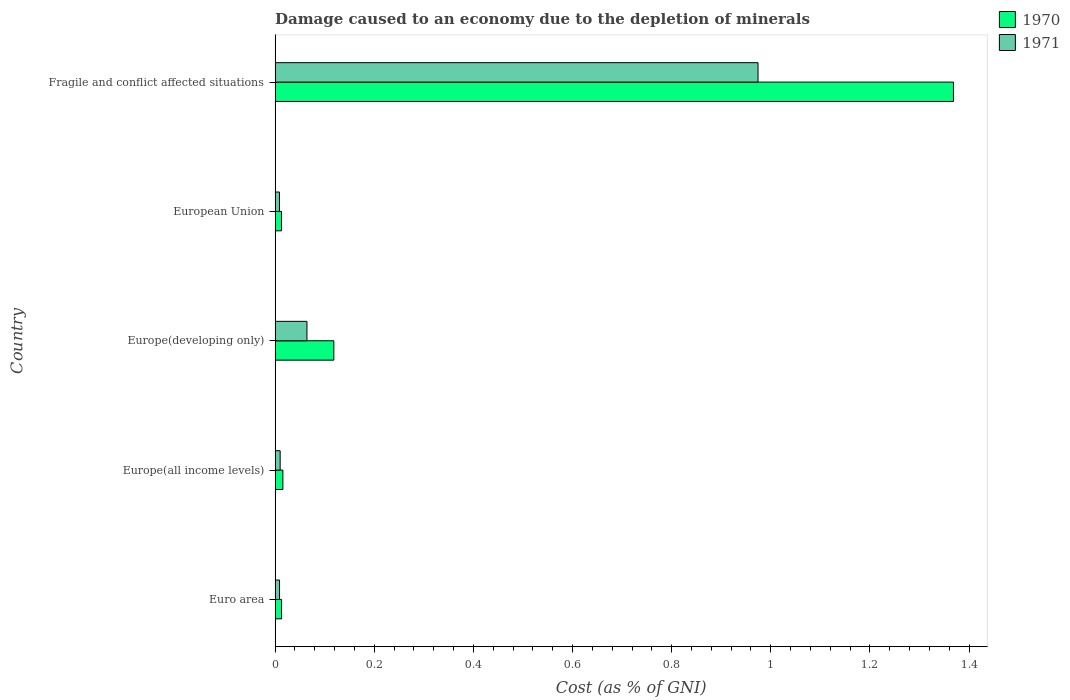How many different coloured bars are there?
Your answer should be compact. 2. How many bars are there on the 5th tick from the bottom?
Give a very brief answer. 2. What is the label of the 2nd group of bars from the top?
Provide a succinct answer. European Union. In how many cases, is the number of bars for a given country not equal to the number of legend labels?
Provide a succinct answer. 0. What is the cost of damage caused due to the depletion of minerals in 1970 in Fragile and conflict affected situations?
Make the answer very short. 1.37. Across all countries, what is the maximum cost of damage caused due to the depletion of minerals in 1971?
Your answer should be compact. 0.97. Across all countries, what is the minimum cost of damage caused due to the depletion of minerals in 1970?
Make the answer very short. 0.01. In which country was the cost of damage caused due to the depletion of minerals in 1971 maximum?
Keep it short and to the point. Fragile and conflict affected situations. In which country was the cost of damage caused due to the depletion of minerals in 1970 minimum?
Keep it short and to the point. European Union. What is the total cost of damage caused due to the depletion of minerals in 1971 in the graph?
Provide a succinct answer. 1.07. What is the difference between the cost of damage caused due to the depletion of minerals in 1970 in Europe(all income levels) and that in European Union?
Provide a short and direct response. 0. What is the difference between the cost of damage caused due to the depletion of minerals in 1970 in Europe(developing only) and the cost of damage caused due to the depletion of minerals in 1971 in European Union?
Give a very brief answer. 0.11. What is the average cost of damage caused due to the depletion of minerals in 1971 per country?
Offer a terse response. 0.21. What is the difference between the cost of damage caused due to the depletion of minerals in 1971 and cost of damage caused due to the depletion of minerals in 1970 in Euro area?
Offer a very short reply. -0. In how many countries, is the cost of damage caused due to the depletion of minerals in 1970 greater than 0.12 %?
Ensure brevity in your answer.  1. What is the ratio of the cost of damage caused due to the depletion of minerals in 1970 in Europe(all income levels) to that in European Union?
Your answer should be very brief. 1.22. Is the cost of damage caused due to the depletion of minerals in 1970 in Europe(all income levels) less than that in European Union?
Make the answer very short. No. What is the difference between the highest and the second highest cost of damage caused due to the depletion of minerals in 1971?
Offer a very short reply. 0.91. What is the difference between the highest and the lowest cost of damage caused due to the depletion of minerals in 1971?
Keep it short and to the point. 0.97. What does the 2nd bar from the top in Europe(developing only) represents?
Offer a very short reply. 1970. What does the 2nd bar from the bottom in Euro area represents?
Offer a terse response. 1971. Are all the bars in the graph horizontal?
Offer a terse response. Yes. How many countries are there in the graph?
Your answer should be very brief. 5. Are the values on the major ticks of X-axis written in scientific E-notation?
Offer a very short reply. No. Does the graph contain any zero values?
Your response must be concise. No. Does the graph contain grids?
Your response must be concise. No. What is the title of the graph?
Ensure brevity in your answer.  Damage caused to an economy due to the depletion of minerals. What is the label or title of the X-axis?
Make the answer very short. Cost (as % of GNI). What is the label or title of the Y-axis?
Provide a short and direct response. Country. What is the Cost (as % of GNI) in 1970 in Euro area?
Ensure brevity in your answer.  0.01. What is the Cost (as % of GNI) of 1971 in Euro area?
Ensure brevity in your answer.  0.01. What is the Cost (as % of GNI) of 1970 in Europe(all income levels)?
Provide a succinct answer. 0.02. What is the Cost (as % of GNI) of 1971 in Europe(all income levels)?
Ensure brevity in your answer.  0.01. What is the Cost (as % of GNI) of 1970 in Europe(developing only)?
Offer a terse response. 0.12. What is the Cost (as % of GNI) of 1971 in Europe(developing only)?
Keep it short and to the point. 0.06. What is the Cost (as % of GNI) of 1970 in European Union?
Your answer should be very brief. 0.01. What is the Cost (as % of GNI) in 1971 in European Union?
Your response must be concise. 0.01. What is the Cost (as % of GNI) of 1970 in Fragile and conflict affected situations?
Offer a terse response. 1.37. What is the Cost (as % of GNI) of 1971 in Fragile and conflict affected situations?
Keep it short and to the point. 0.97. Across all countries, what is the maximum Cost (as % of GNI) of 1970?
Ensure brevity in your answer.  1.37. Across all countries, what is the maximum Cost (as % of GNI) of 1971?
Give a very brief answer. 0.97. Across all countries, what is the minimum Cost (as % of GNI) in 1970?
Offer a terse response. 0.01. Across all countries, what is the minimum Cost (as % of GNI) of 1971?
Your response must be concise. 0.01. What is the total Cost (as % of GNI) of 1970 in the graph?
Provide a short and direct response. 1.53. What is the total Cost (as % of GNI) of 1971 in the graph?
Offer a terse response. 1.07. What is the difference between the Cost (as % of GNI) in 1970 in Euro area and that in Europe(all income levels)?
Ensure brevity in your answer.  -0. What is the difference between the Cost (as % of GNI) in 1971 in Euro area and that in Europe(all income levels)?
Your answer should be compact. -0. What is the difference between the Cost (as % of GNI) of 1970 in Euro area and that in Europe(developing only)?
Your answer should be very brief. -0.11. What is the difference between the Cost (as % of GNI) of 1971 in Euro area and that in Europe(developing only)?
Offer a terse response. -0.06. What is the difference between the Cost (as % of GNI) of 1970 in Euro area and that in Fragile and conflict affected situations?
Offer a very short reply. -1.36. What is the difference between the Cost (as % of GNI) of 1971 in Euro area and that in Fragile and conflict affected situations?
Provide a short and direct response. -0.97. What is the difference between the Cost (as % of GNI) in 1970 in Europe(all income levels) and that in Europe(developing only)?
Provide a succinct answer. -0.1. What is the difference between the Cost (as % of GNI) in 1971 in Europe(all income levels) and that in Europe(developing only)?
Make the answer very short. -0.05. What is the difference between the Cost (as % of GNI) of 1970 in Europe(all income levels) and that in European Union?
Give a very brief answer. 0. What is the difference between the Cost (as % of GNI) of 1971 in Europe(all income levels) and that in European Union?
Offer a very short reply. 0. What is the difference between the Cost (as % of GNI) in 1970 in Europe(all income levels) and that in Fragile and conflict affected situations?
Offer a very short reply. -1.35. What is the difference between the Cost (as % of GNI) in 1971 in Europe(all income levels) and that in Fragile and conflict affected situations?
Keep it short and to the point. -0.96. What is the difference between the Cost (as % of GNI) in 1970 in Europe(developing only) and that in European Union?
Provide a short and direct response. 0.11. What is the difference between the Cost (as % of GNI) of 1971 in Europe(developing only) and that in European Union?
Ensure brevity in your answer.  0.06. What is the difference between the Cost (as % of GNI) in 1970 in Europe(developing only) and that in Fragile and conflict affected situations?
Your answer should be very brief. -1.25. What is the difference between the Cost (as % of GNI) of 1971 in Europe(developing only) and that in Fragile and conflict affected situations?
Your answer should be very brief. -0.91. What is the difference between the Cost (as % of GNI) in 1970 in European Union and that in Fragile and conflict affected situations?
Your answer should be very brief. -1.36. What is the difference between the Cost (as % of GNI) of 1971 in European Union and that in Fragile and conflict affected situations?
Provide a succinct answer. -0.97. What is the difference between the Cost (as % of GNI) in 1970 in Euro area and the Cost (as % of GNI) in 1971 in Europe(all income levels)?
Your answer should be very brief. 0. What is the difference between the Cost (as % of GNI) of 1970 in Euro area and the Cost (as % of GNI) of 1971 in Europe(developing only)?
Your answer should be very brief. -0.05. What is the difference between the Cost (as % of GNI) of 1970 in Euro area and the Cost (as % of GNI) of 1971 in European Union?
Ensure brevity in your answer.  0. What is the difference between the Cost (as % of GNI) in 1970 in Euro area and the Cost (as % of GNI) in 1971 in Fragile and conflict affected situations?
Offer a very short reply. -0.96. What is the difference between the Cost (as % of GNI) of 1970 in Europe(all income levels) and the Cost (as % of GNI) of 1971 in Europe(developing only)?
Offer a very short reply. -0.05. What is the difference between the Cost (as % of GNI) of 1970 in Europe(all income levels) and the Cost (as % of GNI) of 1971 in European Union?
Your response must be concise. 0.01. What is the difference between the Cost (as % of GNI) in 1970 in Europe(all income levels) and the Cost (as % of GNI) in 1971 in Fragile and conflict affected situations?
Keep it short and to the point. -0.96. What is the difference between the Cost (as % of GNI) in 1970 in Europe(developing only) and the Cost (as % of GNI) in 1971 in European Union?
Make the answer very short. 0.11. What is the difference between the Cost (as % of GNI) in 1970 in Europe(developing only) and the Cost (as % of GNI) in 1971 in Fragile and conflict affected situations?
Keep it short and to the point. -0.86. What is the difference between the Cost (as % of GNI) in 1970 in European Union and the Cost (as % of GNI) in 1971 in Fragile and conflict affected situations?
Make the answer very short. -0.96. What is the average Cost (as % of GNI) in 1970 per country?
Offer a very short reply. 0.31. What is the average Cost (as % of GNI) in 1971 per country?
Make the answer very short. 0.21. What is the difference between the Cost (as % of GNI) of 1970 and Cost (as % of GNI) of 1971 in Euro area?
Ensure brevity in your answer.  0. What is the difference between the Cost (as % of GNI) of 1970 and Cost (as % of GNI) of 1971 in Europe(all income levels)?
Your answer should be very brief. 0.01. What is the difference between the Cost (as % of GNI) of 1970 and Cost (as % of GNI) of 1971 in Europe(developing only)?
Your response must be concise. 0.05. What is the difference between the Cost (as % of GNI) in 1970 and Cost (as % of GNI) in 1971 in European Union?
Your answer should be very brief. 0. What is the difference between the Cost (as % of GNI) of 1970 and Cost (as % of GNI) of 1971 in Fragile and conflict affected situations?
Keep it short and to the point. 0.39. What is the ratio of the Cost (as % of GNI) in 1970 in Euro area to that in Europe(all income levels)?
Keep it short and to the point. 0.83. What is the ratio of the Cost (as % of GNI) in 1971 in Euro area to that in Europe(all income levels)?
Your answer should be very brief. 0.88. What is the ratio of the Cost (as % of GNI) in 1970 in Euro area to that in Europe(developing only)?
Your answer should be compact. 0.11. What is the ratio of the Cost (as % of GNI) in 1971 in Euro area to that in Europe(developing only)?
Make the answer very short. 0.14. What is the ratio of the Cost (as % of GNI) of 1971 in Euro area to that in European Union?
Ensure brevity in your answer.  1.02. What is the ratio of the Cost (as % of GNI) in 1970 in Euro area to that in Fragile and conflict affected situations?
Your answer should be very brief. 0.01. What is the ratio of the Cost (as % of GNI) of 1971 in Euro area to that in Fragile and conflict affected situations?
Your response must be concise. 0.01. What is the ratio of the Cost (as % of GNI) of 1970 in Europe(all income levels) to that in Europe(developing only)?
Offer a very short reply. 0.13. What is the ratio of the Cost (as % of GNI) of 1971 in Europe(all income levels) to that in Europe(developing only)?
Provide a succinct answer. 0.16. What is the ratio of the Cost (as % of GNI) in 1970 in Europe(all income levels) to that in European Union?
Your answer should be very brief. 1.22. What is the ratio of the Cost (as % of GNI) in 1971 in Europe(all income levels) to that in European Union?
Your answer should be very brief. 1.16. What is the ratio of the Cost (as % of GNI) of 1970 in Europe(all income levels) to that in Fragile and conflict affected situations?
Provide a succinct answer. 0.01. What is the ratio of the Cost (as % of GNI) in 1971 in Europe(all income levels) to that in Fragile and conflict affected situations?
Keep it short and to the point. 0.01. What is the ratio of the Cost (as % of GNI) in 1970 in Europe(developing only) to that in European Union?
Give a very brief answer. 9.17. What is the ratio of the Cost (as % of GNI) in 1971 in Europe(developing only) to that in European Union?
Your answer should be very brief. 7.27. What is the ratio of the Cost (as % of GNI) of 1970 in Europe(developing only) to that in Fragile and conflict affected situations?
Provide a short and direct response. 0.09. What is the ratio of the Cost (as % of GNI) in 1971 in Europe(developing only) to that in Fragile and conflict affected situations?
Keep it short and to the point. 0.07. What is the ratio of the Cost (as % of GNI) in 1970 in European Union to that in Fragile and conflict affected situations?
Ensure brevity in your answer.  0.01. What is the ratio of the Cost (as % of GNI) in 1971 in European Union to that in Fragile and conflict affected situations?
Your response must be concise. 0.01. What is the difference between the highest and the second highest Cost (as % of GNI) in 1971?
Give a very brief answer. 0.91. What is the difference between the highest and the lowest Cost (as % of GNI) in 1970?
Keep it short and to the point. 1.36. What is the difference between the highest and the lowest Cost (as % of GNI) of 1971?
Make the answer very short. 0.97. 